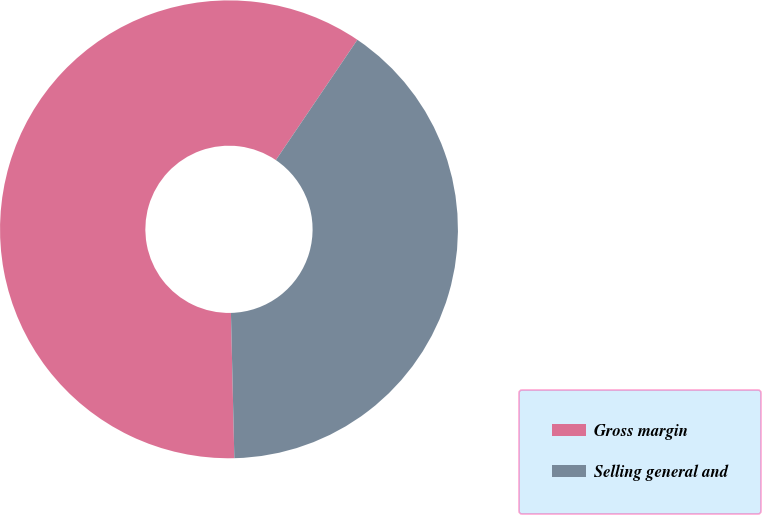<chart> <loc_0><loc_0><loc_500><loc_500><pie_chart><fcel>Gross margin<fcel>Selling general and<nl><fcel>59.85%<fcel>40.15%<nl></chart> 